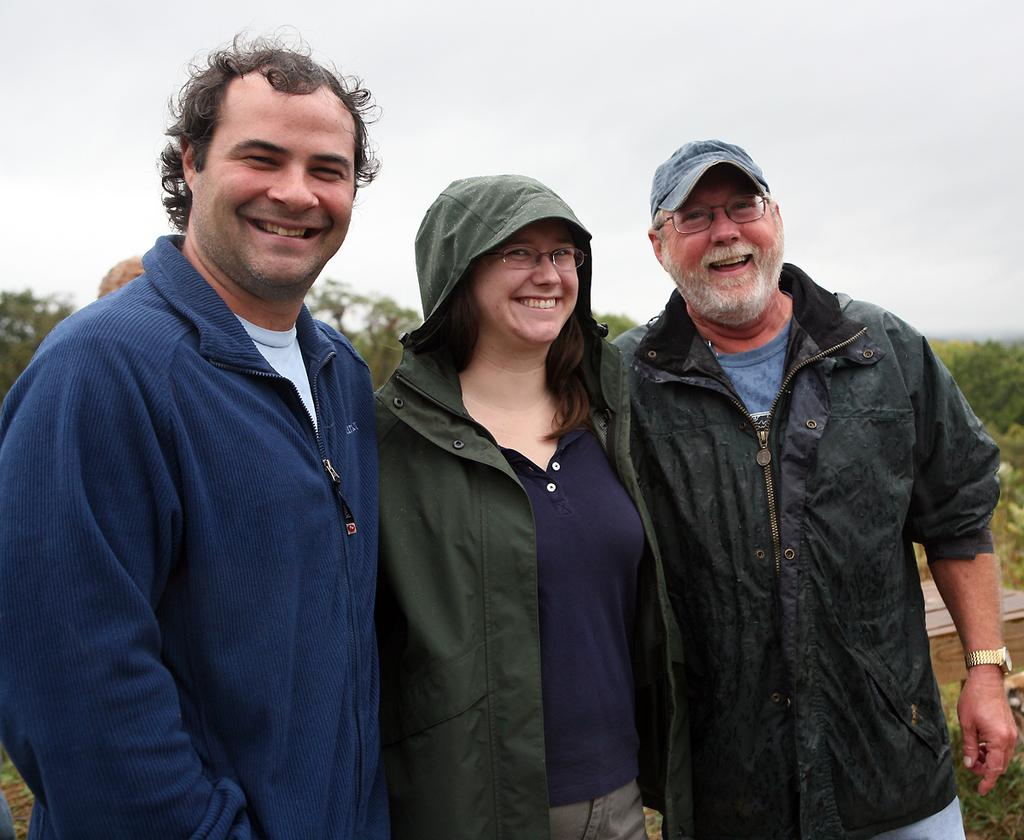How many people are in the foreground of the picture? There are three people standing in the foreground of the picture. What are the people doing in the image? The people are smiling in the image. What can be seen on the right side of the image? There are plants and a box on the right side of the image. What is visible in the background of the image? There are trees and the sky visible in the background of the image. What type of spot can be seen on the people's clothing in the image? There is no specific spot visible on the people's clothing in the image. 